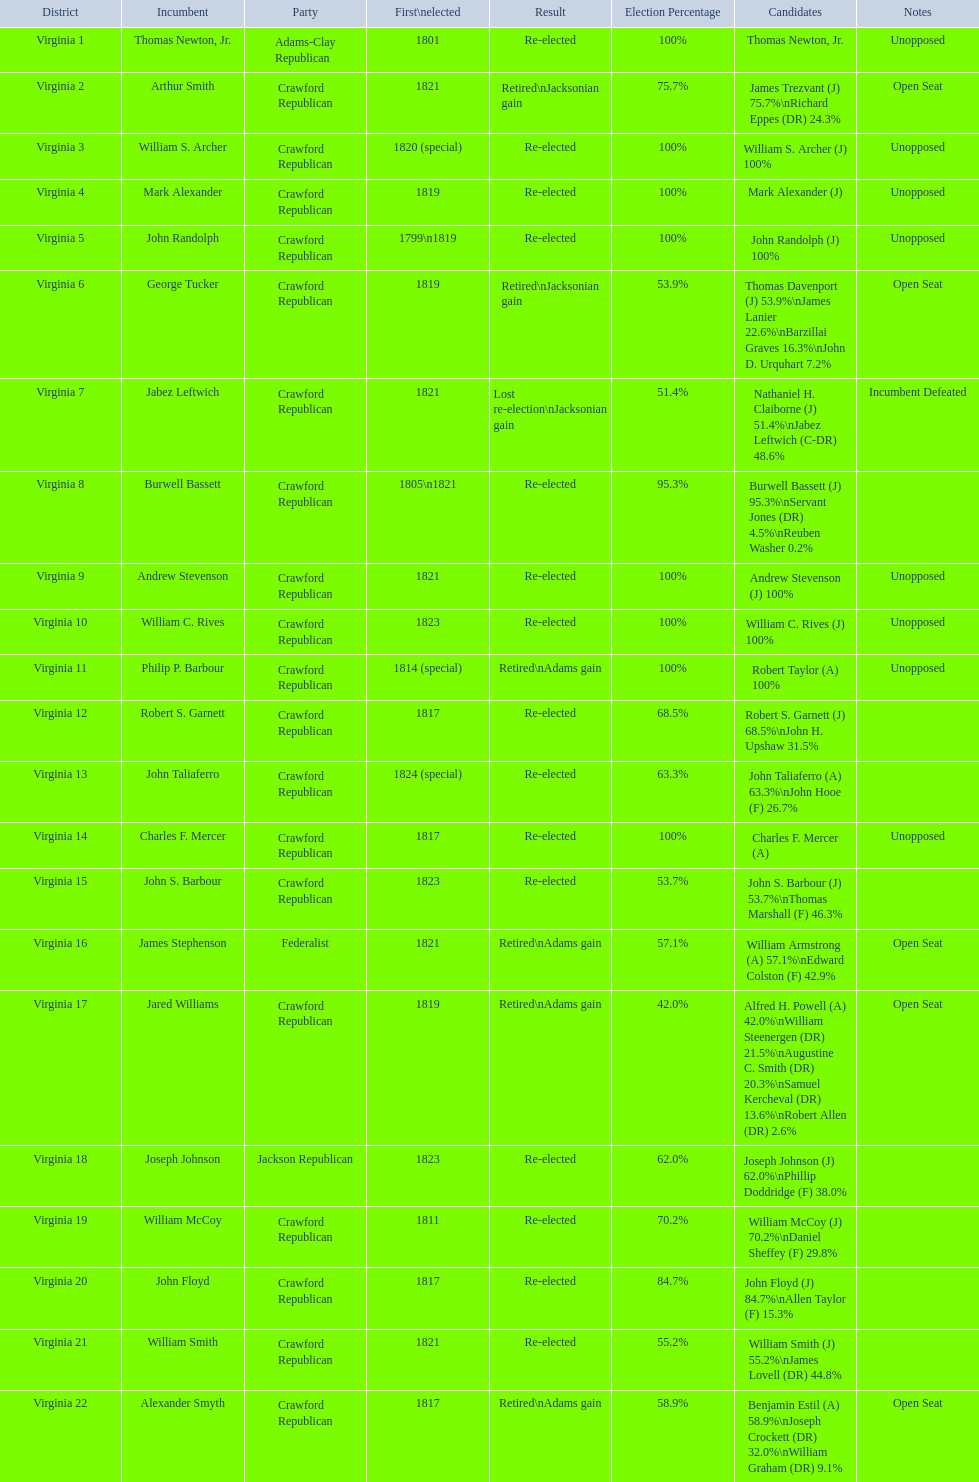Which incumbents belonged to the crawford republican party? Arthur Smith, William S. Archer, Mark Alexander, John Randolph, George Tucker, Jabez Leftwich, Burwell Bassett, Andrew Stevenson, William C. Rives, Philip P. Barbour, Robert S. Garnett, John Taliaferro, Charles F. Mercer, John S. Barbour, Jared Williams, William McCoy, John Floyd, William Smith, Alexander Smyth. Which of these incumbents were first elected in 1821? Arthur Smith, Jabez Leftwich, Andrew Stevenson, William Smith. Which of these incumbents have a last name of smith? Arthur Smith, William Smith. Which of these two were not re-elected? Arthur Smith. 